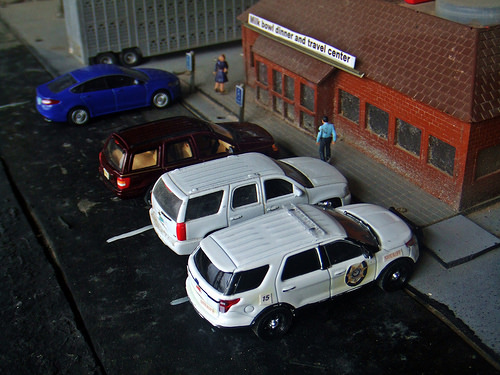<image>
Is the blue car to the left of the back car? Yes. From this viewpoint, the blue car is positioned to the left side relative to the back car. Where is the car in relation to the car? Is it next to the car? Yes. The car is positioned adjacent to the car, located nearby in the same general area. 